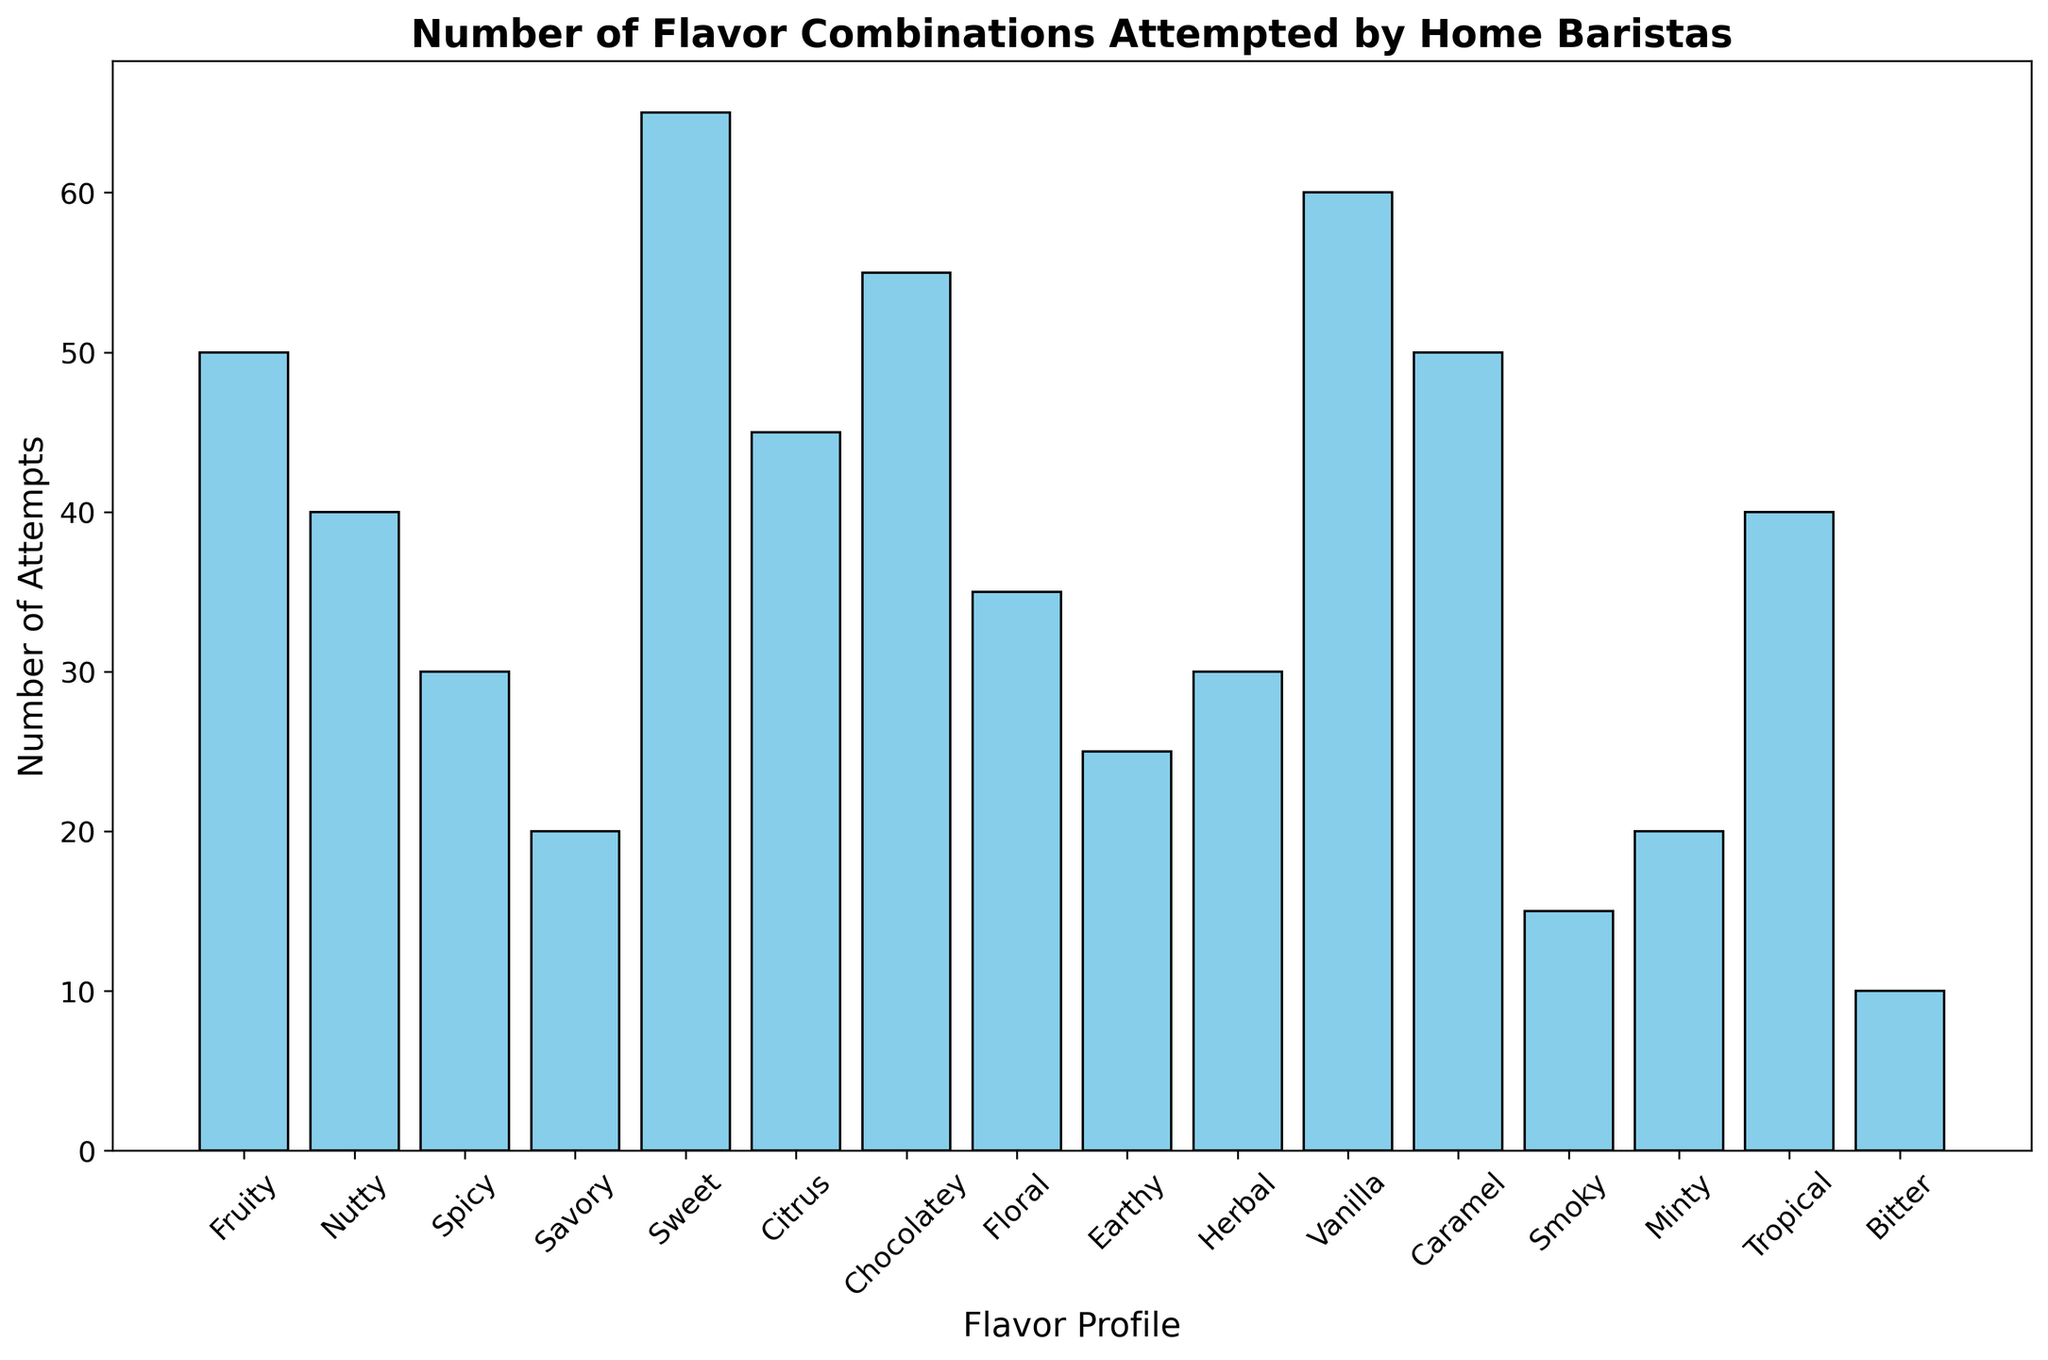What's the flavor profile with the highest number of attempts? The flavor profile with the highest bar represents the highest number of attempts. The 'Sweet' profile has the highest bar.
Answer: Sweet Which two flavor profiles have the same number of attempts? Look for bars of the same height. 'Nutty' and 'Tropical' both have 40 attempts each.
Answer: Nutty, Tropical Compare the number of attempts between 'Fruity' and 'Caramel'. Which one is greater? Compare the heights of the bars for 'Fruity' and 'Caramel'. 'Caramel' is greater than 'Fruity', with 50 attempts for 'Fruity' and 50 attempts for 'Caramel'.
Answer: Equal What's the total number of attempts for 'Nutty', 'Spicy', and 'Herbal' combined? Sum the numbers for 'Nutty', 'Spicy', and 'Herbal'. 40 (Nutty) + 30 (Spicy) + 30 (Herbal) = 100.
Answer: 100 Which flavor profile has the least number of attempts and how many are there? The shortest bar represents the least number of attempts. 'Bitter' is the shortest with 10 attempts.
Answer: Bitter, 10 What's the average number of attempts across all flavor profiles? Sum all the attempt counts and divide by the number of profiles. Sum: 50 + 40 + 30 + 20 + 65 + 45 + 55 + 35 + 25 + 30 + 60 + 50 + 15 + 20 + 40 + 10 = 590. There are 16 profiles, so the average is 590/16 = 36.875.
Answer: 36.875 Compare the combined number of attempts for 'Floral' and 'Vanilla' with 'Chocolatey'. Which is greater? Add the attempts for 'Floral' and 'Vanilla', and compare with 'Chocolatey'. 35 (Floral) + 60 (Vanilla) = 95, which is greater than 55 (Chocolatey).
Answer: Floral and Vanilla What is the difference in the number of attempts between 'Savory' and 'Minty'? Subtract the attempts for 'Savory' from 'Minty'. 20 (Minty) - 20 (Savory) = 0.
Answer: 0 